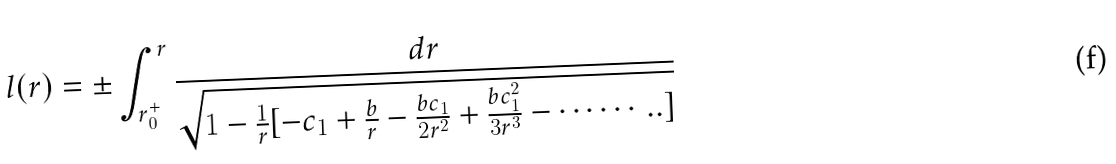<formula> <loc_0><loc_0><loc_500><loc_500>l ( r ) = \pm \int _ { r _ { 0 } ^ { + } } ^ { r } \frac { d r } { \sqrt { 1 - \frac { 1 } { r } [ - c _ { 1 } + \frac { b } { r } - \frac { b c _ { 1 } } { 2 r ^ { 2 } } + \frac { b c _ { 1 } ^ { 2 } } { 3 r ^ { 3 } } - \cdots \cdots . . ] } }</formula> 